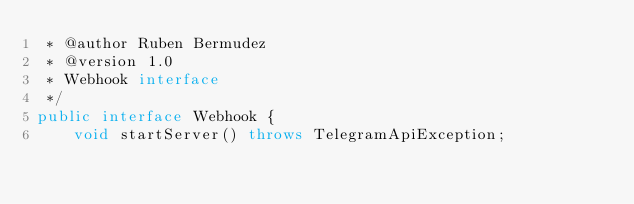Convert code to text. <code><loc_0><loc_0><loc_500><loc_500><_Java_> * @author Ruben Bermudez
 * @version 1.0
 * Webhook interface
 */
public interface Webhook {
    void startServer() throws TelegramApiException;</code> 